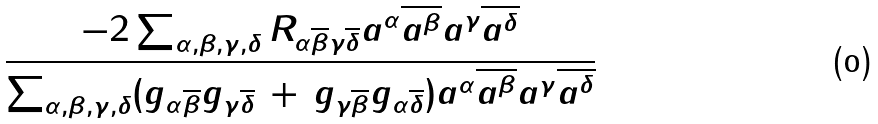<formula> <loc_0><loc_0><loc_500><loc_500>\frac { - 2 \sum _ { \alpha , \beta , \gamma , \delta } R _ { \alpha \overline { \beta } \gamma \overline { \delta } } a ^ { \alpha } \overline { a ^ { \beta } } a ^ { \gamma } \overline { a ^ { \delta } } } { \sum _ { \alpha , \beta , \gamma , \delta } ( g _ { \alpha \overline { \beta } } g _ { \gamma \overline { \delta } } \, + \, g _ { \gamma \overline { \beta } } g _ { \alpha \overline { \delta } } ) a ^ { \alpha } \overline { a ^ { \beta } } a ^ { \gamma } \overline { a ^ { \delta } } }</formula> 